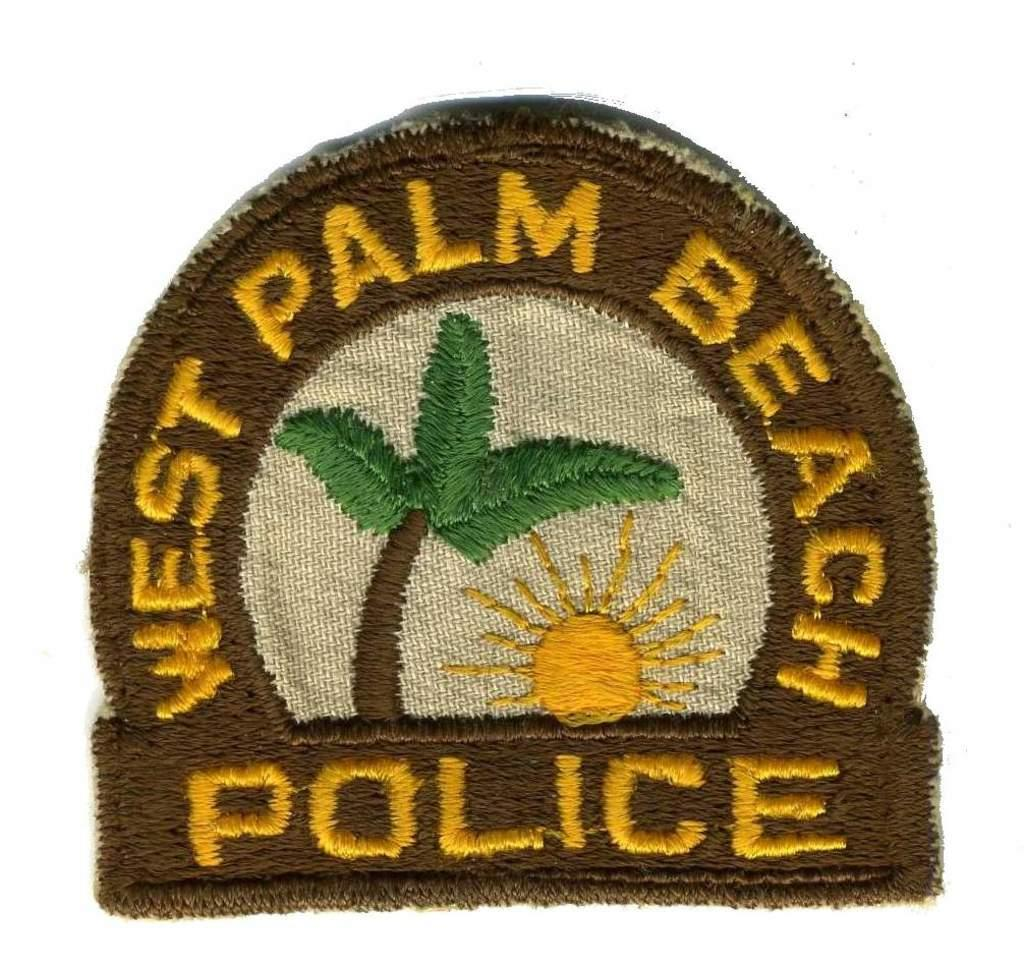<image>
Offer a succinct explanation of the picture presented. West Palm Beach police patch that can be sewn on to anything. 